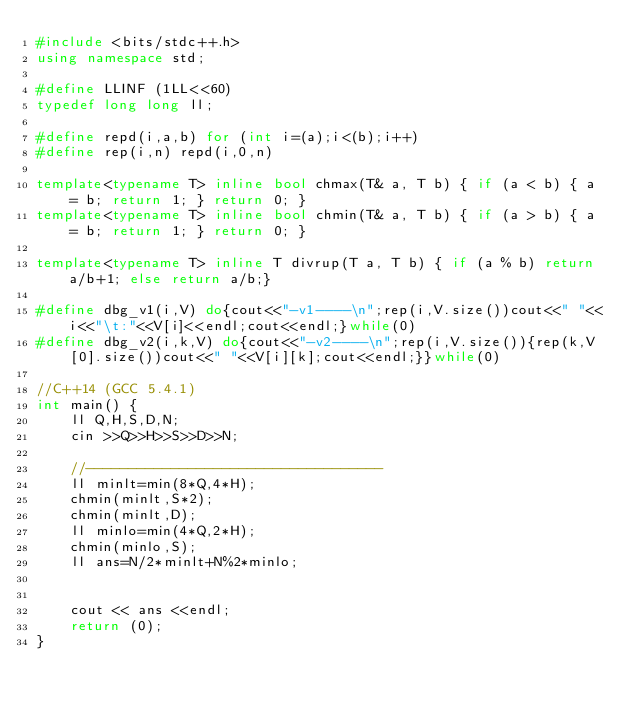Convert code to text. <code><loc_0><loc_0><loc_500><loc_500><_C++_>#include <bits/stdc++.h>
using namespace std;

#define LLINF (1LL<<60)
typedef long long ll;

#define repd(i,a,b) for (int i=(a);i<(b);i++)
#define rep(i,n) repd(i,0,n)

template<typename T> inline bool chmax(T& a, T b) { if (a < b) { a = b; return 1; } return 0; }
template<typename T> inline bool chmin(T& a, T b) { if (a > b) { a = b; return 1; } return 0; }

template<typename T> inline T divrup(T a, T b) { if (a % b) return a/b+1; else return a/b;}

#define dbg_v1(i,V) do{cout<<"-v1----\n";rep(i,V.size())cout<<" "<<i<<"\t:"<<V[i]<<endl;cout<<endl;}while(0)
#define dbg_v2(i,k,V) do{cout<<"-v2----\n";rep(i,V.size()){rep(k,V[0].size())cout<<" "<<V[i][k];cout<<endl;}}while(0)

//C++14 (GCC 5.4.1)
int main() {
    ll Q,H,S,D,N;
    cin >>Q>>H>>S>>D>>N;

    //-----------------------------------
    ll minlt=min(8*Q,4*H);
    chmin(minlt,S*2);
    chmin(minlt,D);
    ll minlo=min(4*Q,2*H);
    chmin(minlo,S);
    ll ans=N/2*minlt+N%2*minlo;
    

    cout << ans <<endl;
    return (0);
}</code> 